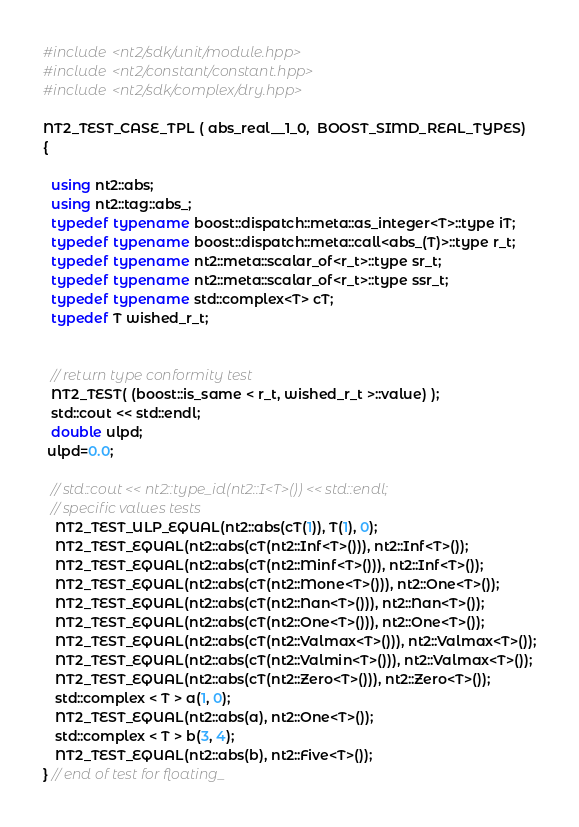Convert code to text. <code><loc_0><loc_0><loc_500><loc_500><_C++_>#include <nt2/sdk/unit/module.hpp>
#include <nt2/constant/constant.hpp>
#include <nt2/sdk/complex/dry.hpp>

NT2_TEST_CASE_TPL ( abs_real__1_0,  BOOST_SIMD_REAL_TYPES)
{

  using nt2::abs;
  using nt2::tag::abs_;
  typedef typename boost::dispatch::meta::as_integer<T>::type iT;
  typedef typename boost::dispatch::meta::call<abs_(T)>::type r_t;
  typedef typename nt2::meta::scalar_of<r_t>::type sr_t;
  typedef typename nt2::meta::scalar_of<r_t>::type ssr_t;
  typedef typename std::complex<T> cT;
  typedef T wished_r_t;


  // return type conformity test
  NT2_TEST( (boost::is_same < r_t, wished_r_t >::value) );
  std::cout << std::endl;
  double ulpd;
 ulpd=0.0;

  // std::cout << nt2::type_id(nt2::I<T>()) << std::endl;
  // specific values tests
   NT2_TEST_ULP_EQUAL(nt2::abs(cT(1)), T(1), 0);
   NT2_TEST_EQUAL(nt2::abs(cT(nt2::Inf<T>())), nt2::Inf<T>());
   NT2_TEST_EQUAL(nt2::abs(cT(nt2::Minf<T>())), nt2::Inf<T>());
   NT2_TEST_EQUAL(nt2::abs(cT(nt2::Mone<T>())), nt2::One<T>());
   NT2_TEST_EQUAL(nt2::abs(cT(nt2::Nan<T>())), nt2::Nan<T>());
   NT2_TEST_EQUAL(nt2::abs(cT(nt2::One<T>())), nt2::One<T>());
   NT2_TEST_EQUAL(nt2::abs(cT(nt2::Valmax<T>())), nt2::Valmax<T>());
   NT2_TEST_EQUAL(nt2::abs(cT(nt2::Valmin<T>())), nt2::Valmax<T>());
   NT2_TEST_EQUAL(nt2::abs(cT(nt2::Zero<T>())), nt2::Zero<T>());
   std::complex < T > a(1, 0);
   NT2_TEST_EQUAL(nt2::abs(a), nt2::One<T>());
   std::complex < T > b(3, 4);
   NT2_TEST_EQUAL(nt2::abs(b), nt2::Five<T>());
} // end of test for floating_

</code> 